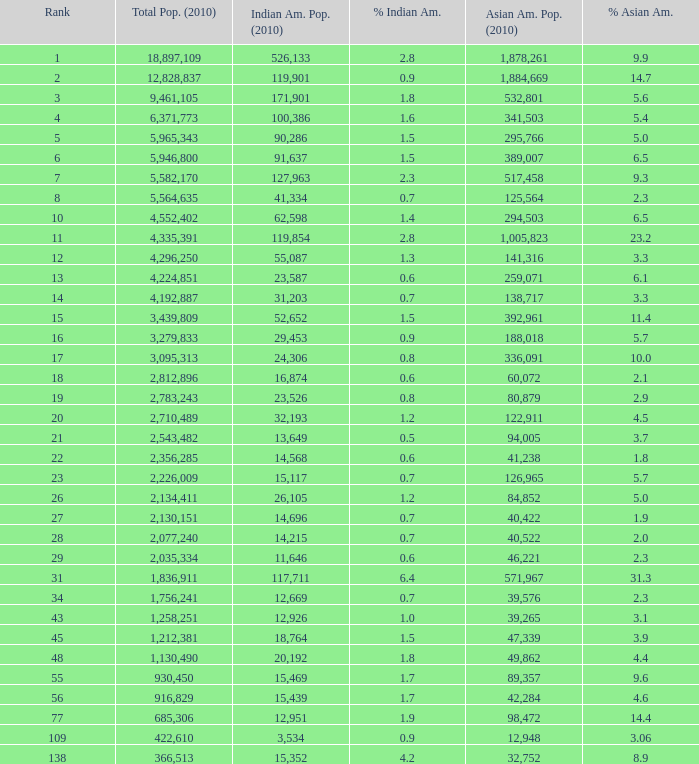What's the total population when there are 5.7% Asian American and fewer than 126,965 Asian American Population? None. 